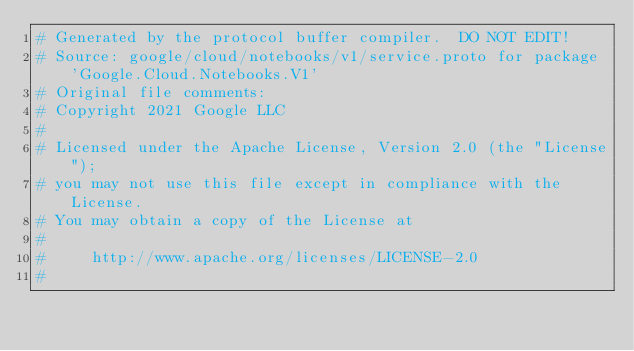Convert code to text. <code><loc_0><loc_0><loc_500><loc_500><_Ruby_># Generated by the protocol buffer compiler.  DO NOT EDIT!
# Source: google/cloud/notebooks/v1/service.proto for package 'Google.Cloud.Notebooks.V1'
# Original file comments:
# Copyright 2021 Google LLC
#
# Licensed under the Apache License, Version 2.0 (the "License");
# you may not use this file except in compliance with the License.
# You may obtain a copy of the License at
#
#     http://www.apache.org/licenses/LICENSE-2.0
#</code> 